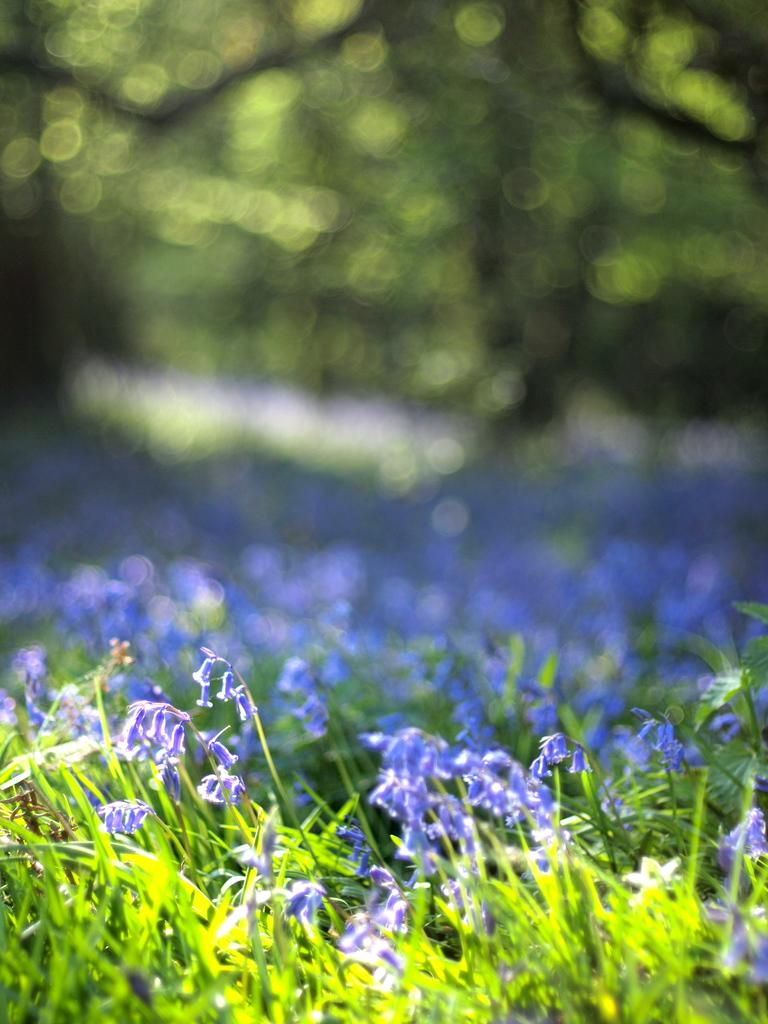What types of vegetation are present at the bottom of the image? There are plants and flowers at the bottom of the image. Can you describe the background of the image? The background of the image is blurry. What type of window can be seen in the image? There is no window present in the image; it only features plants and flowers at the bottom and a blurry background. 